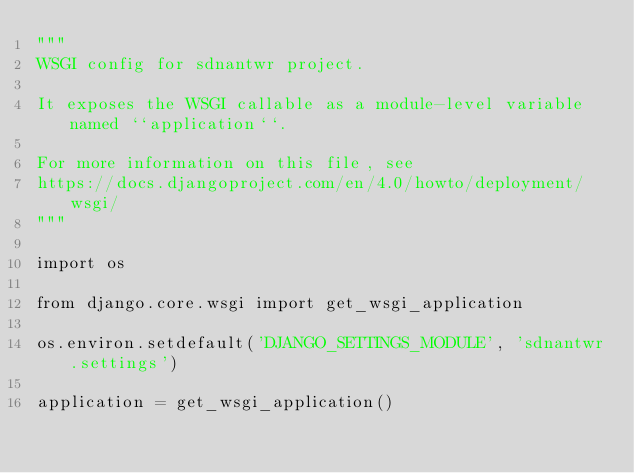Convert code to text. <code><loc_0><loc_0><loc_500><loc_500><_Python_>"""
WSGI config for sdnantwr project.

It exposes the WSGI callable as a module-level variable named ``application``.

For more information on this file, see
https://docs.djangoproject.com/en/4.0/howto/deployment/wsgi/
"""

import os

from django.core.wsgi import get_wsgi_application

os.environ.setdefault('DJANGO_SETTINGS_MODULE', 'sdnantwr.settings')

application = get_wsgi_application()
</code> 